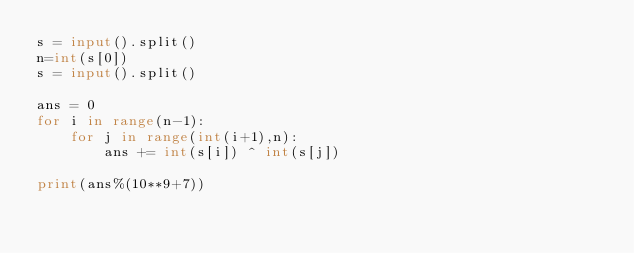<code> <loc_0><loc_0><loc_500><loc_500><_Python_>s = input().split()
n=int(s[0])
s = input().split()

ans = 0
for i in range(n-1):
    for j in range(int(i+1),n):
        ans += int(s[i]) ^ int(s[j])

print(ans%(10**9+7))</code> 